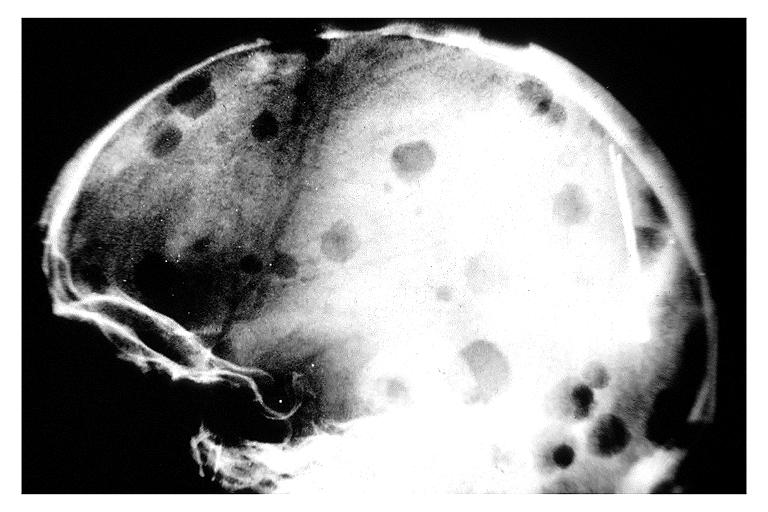does neurofibrillary change show multiple myeloma?
Answer the question using a single word or phrase. No 